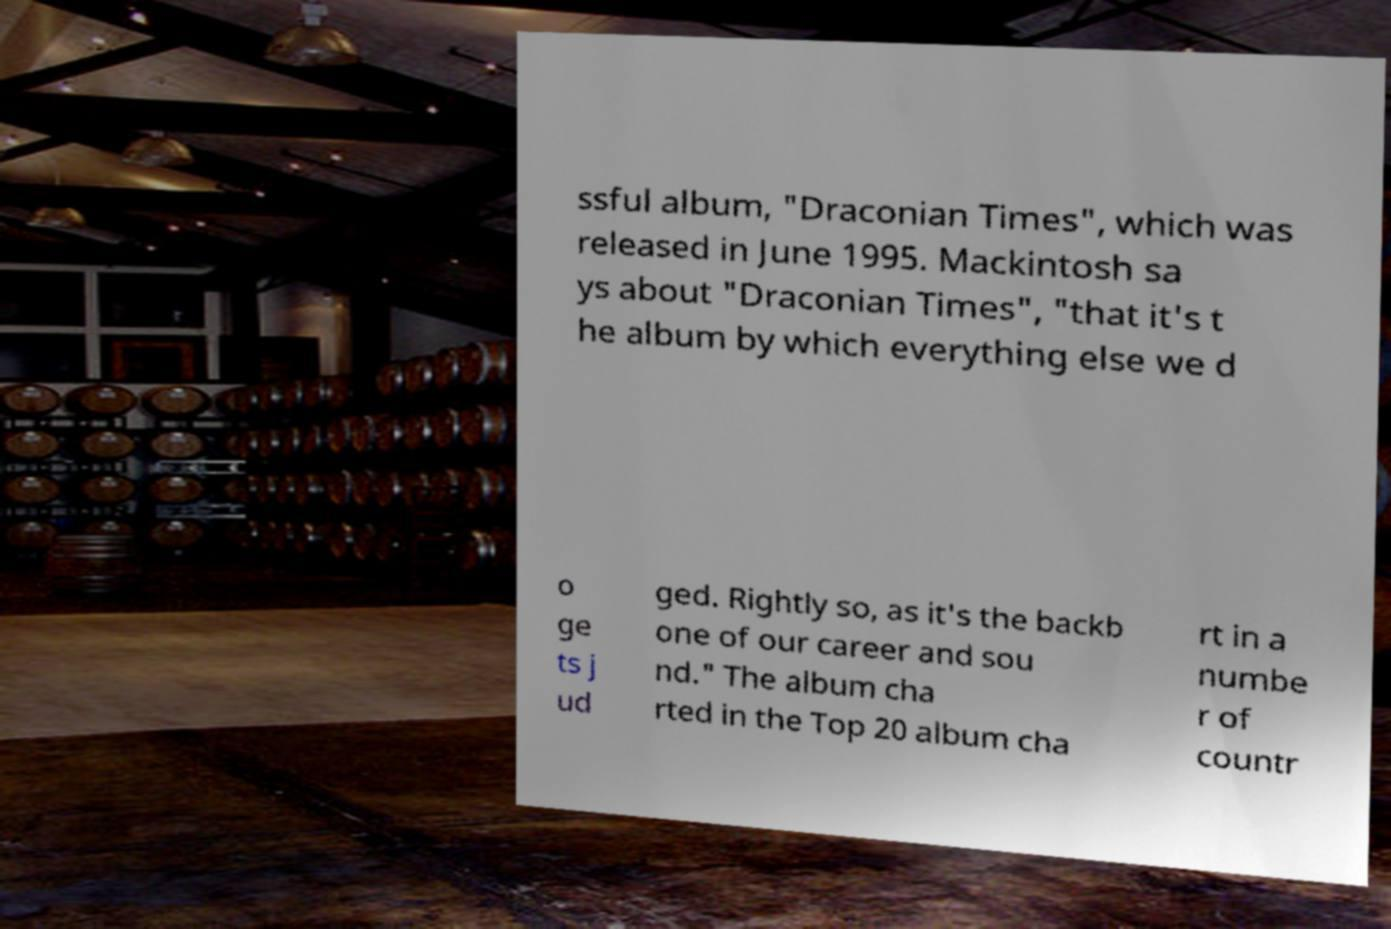Could you extract and type out the text from this image? ssful album, "Draconian Times", which was released in June 1995. Mackintosh sa ys about "Draconian Times", "that it's t he album by which everything else we d o ge ts j ud ged. Rightly so, as it's the backb one of our career and sou nd." The album cha rted in the Top 20 album cha rt in a numbe r of countr 